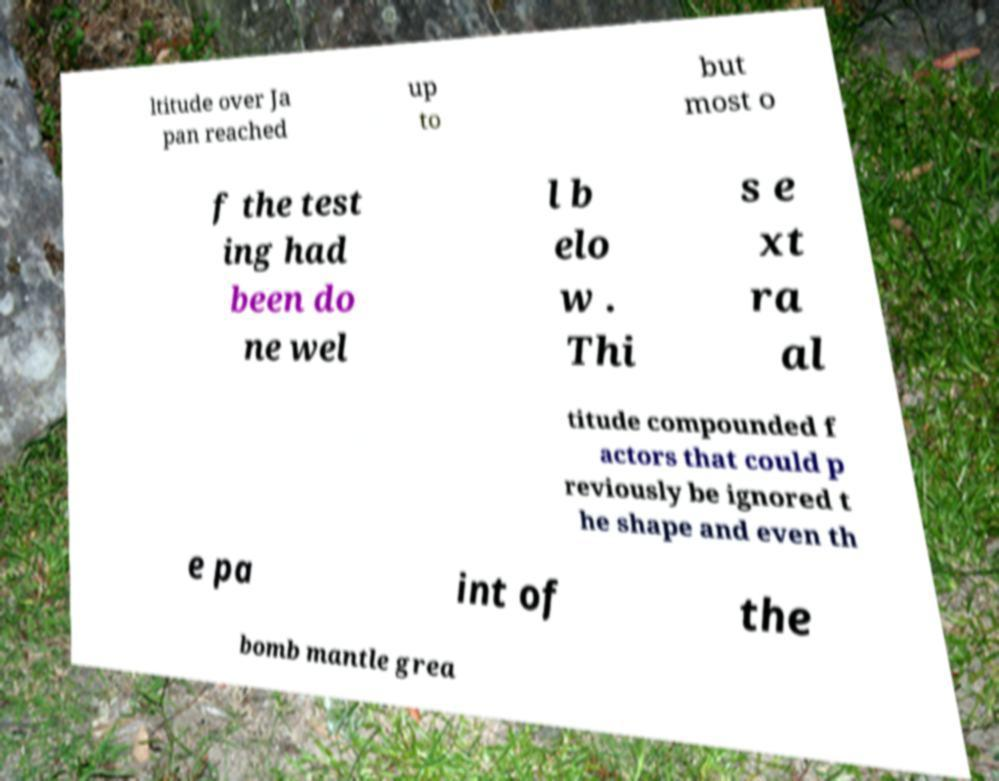Could you assist in decoding the text presented in this image and type it out clearly? ltitude over Ja pan reached up to but most o f the test ing had been do ne wel l b elo w . Thi s e xt ra al titude compounded f actors that could p reviously be ignored t he shape and even th e pa int of the bomb mantle grea 